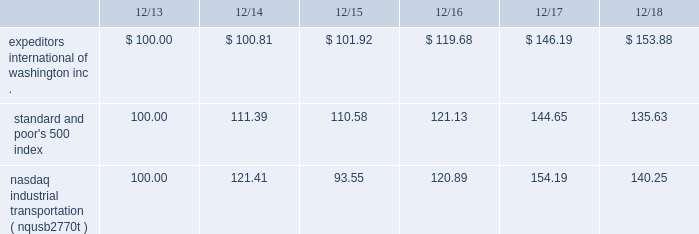The graph below compares expeditors international of washington , inc.'s cumulative 5-year total shareholder return on common stock with the cumulative total returns of the s&p 500 index and the nasdaq industrial transportation index ( nqusb2770t ) .
The graph assumes that the value of the investment in our common stock and in each of the indexes ( including reinvestment of dividends ) was $ 100 on 12/31/2013 and tracks it through 12/31/2018 .
Total return assumes reinvestment of dividends in each of the indices indicated .
Comparison of 5-year cumulative total return among expeditors international of washington , inc. , the s&p 500 index and the nasdaq industrial transportation index. .
The stock price performance included in this graph is not necessarily indicative of future stock price performance. .
What is the difference in percentage of cumulative total return between expeditors international of washington inc . and the standard and poor's 500 index for the 5 year period ending 12/18? 
Computations: (153.88 - 100)
Answer: 53.88. 